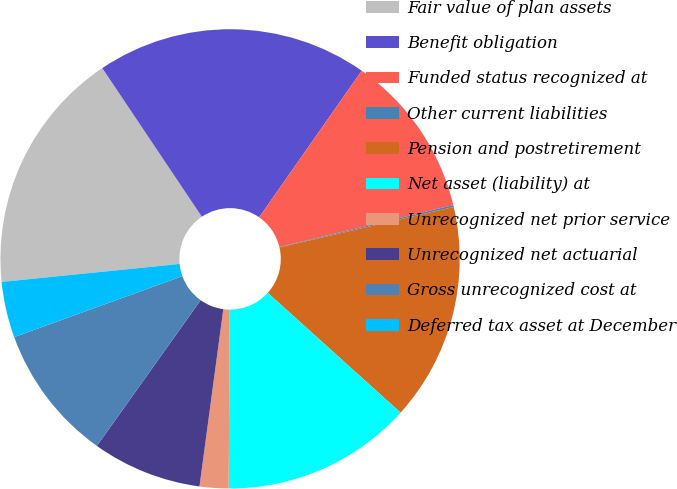<chart> <loc_0><loc_0><loc_500><loc_500><pie_chart><fcel>Fair value of plan assets<fcel>Benefit obligation<fcel>Funded status recognized at<fcel>Other current liabilities<fcel>Pension and postretirement<fcel>Net asset (liability) at<fcel>Unrecognized net prior service<fcel>Unrecognized net actuarial<fcel>Gross unrecognized cost at<fcel>Deferred tax asset at December<nl><fcel>17.21%<fcel>19.11%<fcel>11.52%<fcel>0.13%<fcel>15.31%<fcel>13.42%<fcel>2.03%<fcel>7.72%<fcel>9.62%<fcel>3.93%<nl></chart> 